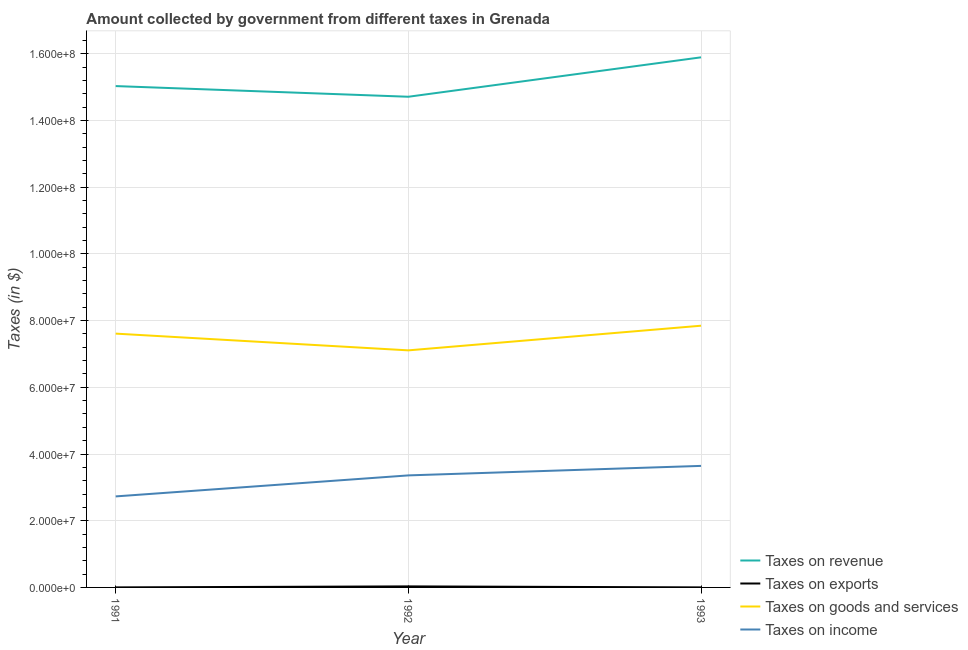What is the amount collected as tax on exports in 1992?
Make the answer very short. 3.10e+05. Across all years, what is the maximum amount collected as tax on income?
Provide a short and direct response. 3.64e+07. Across all years, what is the minimum amount collected as tax on goods?
Make the answer very short. 7.11e+07. In which year was the amount collected as tax on income maximum?
Provide a short and direct response. 1993. In which year was the amount collected as tax on goods minimum?
Your answer should be compact. 1992. What is the total amount collected as tax on income in the graph?
Ensure brevity in your answer.  9.73e+07. What is the difference between the amount collected as tax on exports in 1992 and that in 1993?
Ensure brevity in your answer.  3.00e+05. What is the difference between the amount collected as tax on goods in 1992 and the amount collected as tax on exports in 1991?
Give a very brief answer. 7.11e+07. In the year 1993, what is the difference between the amount collected as tax on goods and amount collected as tax on revenue?
Provide a succinct answer. -8.05e+07. Is the amount collected as tax on income in 1992 less than that in 1993?
Provide a succinct answer. Yes. Is the difference between the amount collected as tax on income in 1991 and 1992 greater than the difference between the amount collected as tax on exports in 1991 and 1992?
Provide a succinct answer. No. What is the difference between the highest and the second highest amount collected as tax on goods?
Offer a very short reply. 2.37e+06. What is the difference between the highest and the lowest amount collected as tax on revenue?
Your answer should be compact. 1.18e+07. Is the sum of the amount collected as tax on income in 1992 and 1993 greater than the maximum amount collected as tax on exports across all years?
Keep it short and to the point. Yes. Does the amount collected as tax on goods monotonically increase over the years?
Keep it short and to the point. No. How many lines are there?
Your response must be concise. 4. How many years are there in the graph?
Offer a terse response. 3. What is the difference between two consecutive major ticks on the Y-axis?
Keep it short and to the point. 2.00e+07. Are the values on the major ticks of Y-axis written in scientific E-notation?
Your response must be concise. Yes. Does the graph contain any zero values?
Give a very brief answer. No. What is the title of the graph?
Give a very brief answer. Amount collected by government from different taxes in Grenada. What is the label or title of the X-axis?
Provide a succinct answer. Year. What is the label or title of the Y-axis?
Your answer should be compact. Taxes (in $). What is the Taxes (in $) in Taxes on revenue in 1991?
Offer a very short reply. 1.50e+08. What is the Taxes (in $) in Taxes on exports in 1991?
Provide a succinct answer. 10000. What is the Taxes (in $) in Taxes on goods and services in 1991?
Provide a short and direct response. 7.61e+07. What is the Taxes (in $) of Taxes on income in 1991?
Your response must be concise. 2.73e+07. What is the Taxes (in $) in Taxes on revenue in 1992?
Your answer should be very brief. 1.47e+08. What is the Taxes (in $) in Taxes on goods and services in 1992?
Provide a short and direct response. 7.11e+07. What is the Taxes (in $) in Taxes on income in 1992?
Offer a terse response. 3.36e+07. What is the Taxes (in $) in Taxes on revenue in 1993?
Make the answer very short. 1.59e+08. What is the Taxes (in $) of Taxes on goods and services in 1993?
Your answer should be compact. 7.85e+07. What is the Taxes (in $) in Taxes on income in 1993?
Your answer should be compact. 3.64e+07. Across all years, what is the maximum Taxes (in $) in Taxes on revenue?
Give a very brief answer. 1.59e+08. Across all years, what is the maximum Taxes (in $) in Taxes on exports?
Provide a short and direct response. 3.10e+05. Across all years, what is the maximum Taxes (in $) of Taxes on goods and services?
Offer a terse response. 7.85e+07. Across all years, what is the maximum Taxes (in $) in Taxes on income?
Give a very brief answer. 3.64e+07. Across all years, what is the minimum Taxes (in $) in Taxes on revenue?
Provide a short and direct response. 1.47e+08. Across all years, what is the minimum Taxes (in $) of Taxes on goods and services?
Your answer should be compact. 7.11e+07. Across all years, what is the minimum Taxes (in $) in Taxes on income?
Provide a short and direct response. 2.73e+07. What is the total Taxes (in $) of Taxes on revenue in the graph?
Give a very brief answer. 4.56e+08. What is the total Taxes (in $) of Taxes on goods and services in the graph?
Offer a very short reply. 2.26e+08. What is the total Taxes (in $) of Taxes on income in the graph?
Keep it short and to the point. 9.73e+07. What is the difference between the Taxes (in $) of Taxes on revenue in 1991 and that in 1992?
Offer a very short reply. 3.20e+06. What is the difference between the Taxes (in $) of Taxes on exports in 1991 and that in 1992?
Make the answer very short. -3.00e+05. What is the difference between the Taxes (in $) in Taxes on goods and services in 1991 and that in 1992?
Your answer should be very brief. 5.02e+06. What is the difference between the Taxes (in $) in Taxes on income in 1991 and that in 1992?
Provide a succinct answer. -6.30e+06. What is the difference between the Taxes (in $) of Taxes on revenue in 1991 and that in 1993?
Make the answer very short. -8.62e+06. What is the difference between the Taxes (in $) in Taxes on goods and services in 1991 and that in 1993?
Make the answer very short. -2.37e+06. What is the difference between the Taxes (in $) in Taxes on income in 1991 and that in 1993?
Your answer should be compact. -9.15e+06. What is the difference between the Taxes (in $) of Taxes on revenue in 1992 and that in 1993?
Offer a terse response. -1.18e+07. What is the difference between the Taxes (in $) in Taxes on exports in 1992 and that in 1993?
Ensure brevity in your answer.  3.00e+05. What is the difference between the Taxes (in $) in Taxes on goods and services in 1992 and that in 1993?
Offer a very short reply. -7.39e+06. What is the difference between the Taxes (in $) in Taxes on income in 1992 and that in 1993?
Offer a terse response. -2.85e+06. What is the difference between the Taxes (in $) of Taxes on revenue in 1991 and the Taxes (in $) of Taxes on exports in 1992?
Offer a very short reply. 1.50e+08. What is the difference between the Taxes (in $) in Taxes on revenue in 1991 and the Taxes (in $) in Taxes on goods and services in 1992?
Keep it short and to the point. 7.92e+07. What is the difference between the Taxes (in $) of Taxes on revenue in 1991 and the Taxes (in $) of Taxes on income in 1992?
Keep it short and to the point. 1.17e+08. What is the difference between the Taxes (in $) in Taxes on exports in 1991 and the Taxes (in $) in Taxes on goods and services in 1992?
Your response must be concise. -7.11e+07. What is the difference between the Taxes (in $) in Taxes on exports in 1991 and the Taxes (in $) in Taxes on income in 1992?
Ensure brevity in your answer.  -3.36e+07. What is the difference between the Taxes (in $) of Taxes on goods and services in 1991 and the Taxes (in $) of Taxes on income in 1992?
Your answer should be compact. 4.25e+07. What is the difference between the Taxes (in $) of Taxes on revenue in 1991 and the Taxes (in $) of Taxes on exports in 1993?
Offer a terse response. 1.50e+08. What is the difference between the Taxes (in $) of Taxes on revenue in 1991 and the Taxes (in $) of Taxes on goods and services in 1993?
Provide a succinct answer. 7.18e+07. What is the difference between the Taxes (in $) in Taxes on revenue in 1991 and the Taxes (in $) in Taxes on income in 1993?
Keep it short and to the point. 1.14e+08. What is the difference between the Taxes (in $) of Taxes on exports in 1991 and the Taxes (in $) of Taxes on goods and services in 1993?
Offer a very short reply. -7.85e+07. What is the difference between the Taxes (in $) in Taxes on exports in 1991 and the Taxes (in $) in Taxes on income in 1993?
Provide a short and direct response. -3.64e+07. What is the difference between the Taxes (in $) of Taxes on goods and services in 1991 and the Taxes (in $) of Taxes on income in 1993?
Your answer should be very brief. 3.97e+07. What is the difference between the Taxes (in $) of Taxes on revenue in 1992 and the Taxes (in $) of Taxes on exports in 1993?
Give a very brief answer. 1.47e+08. What is the difference between the Taxes (in $) of Taxes on revenue in 1992 and the Taxes (in $) of Taxes on goods and services in 1993?
Give a very brief answer. 6.86e+07. What is the difference between the Taxes (in $) in Taxes on revenue in 1992 and the Taxes (in $) in Taxes on income in 1993?
Offer a very short reply. 1.11e+08. What is the difference between the Taxes (in $) of Taxes on exports in 1992 and the Taxes (in $) of Taxes on goods and services in 1993?
Provide a short and direct response. -7.82e+07. What is the difference between the Taxes (in $) of Taxes on exports in 1992 and the Taxes (in $) of Taxes on income in 1993?
Your answer should be compact. -3.61e+07. What is the difference between the Taxes (in $) of Taxes on goods and services in 1992 and the Taxes (in $) of Taxes on income in 1993?
Your answer should be very brief. 3.46e+07. What is the average Taxes (in $) of Taxes on revenue per year?
Provide a succinct answer. 1.52e+08. What is the average Taxes (in $) of Taxes on goods and services per year?
Ensure brevity in your answer.  7.52e+07. What is the average Taxes (in $) in Taxes on income per year?
Offer a terse response. 3.24e+07. In the year 1991, what is the difference between the Taxes (in $) in Taxes on revenue and Taxes (in $) in Taxes on exports?
Give a very brief answer. 1.50e+08. In the year 1991, what is the difference between the Taxes (in $) of Taxes on revenue and Taxes (in $) of Taxes on goods and services?
Offer a very short reply. 7.42e+07. In the year 1991, what is the difference between the Taxes (in $) in Taxes on revenue and Taxes (in $) in Taxes on income?
Ensure brevity in your answer.  1.23e+08. In the year 1991, what is the difference between the Taxes (in $) in Taxes on exports and Taxes (in $) in Taxes on goods and services?
Give a very brief answer. -7.61e+07. In the year 1991, what is the difference between the Taxes (in $) in Taxes on exports and Taxes (in $) in Taxes on income?
Offer a terse response. -2.73e+07. In the year 1991, what is the difference between the Taxes (in $) in Taxes on goods and services and Taxes (in $) in Taxes on income?
Your response must be concise. 4.88e+07. In the year 1992, what is the difference between the Taxes (in $) in Taxes on revenue and Taxes (in $) in Taxes on exports?
Your response must be concise. 1.47e+08. In the year 1992, what is the difference between the Taxes (in $) of Taxes on revenue and Taxes (in $) of Taxes on goods and services?
Give a very brief answer. 7.60e+07. In the year 1992, what is the difference between the Taxes (in $) of Taxes on revenue and Taxes (in $) of Taxes on income?
Keep it short and to the point. 1.14e+08. In the year 1992, what is the difference between the Taxes (in $) of Taxes on exports and Taxes (in $) of Taxes on goods and services?
Give a very brief answer. -7.08e+07. In the year 1992, what is the difference between the Taxes (in $) of Taxes on exports and Taxes (in $) of Taxes on income?
Keep it short and to the point. -3.33e+07. In the year 1992, what is the difference between the Taxes (in $) in Taxes on goods and services and Taxes (in $) in Taxes on income?
Make the answer very short. 3.75e+07. In the year 1993, what is the difference between the Taxes (in $) in Taxes on revenue and Taxes (in $) in Taxes on exports?
Offer a terse response. 1.59e+08. In the year 1993, what is the difference between the Taxes (in $) in Taxes on revenue and Taxes (in $) in Taxes on goods and services?
Your response must be concise. 8.05e+07. In the year 1993, what is the difference between the Taxes (in $) of Taxes on revenue and Taxes (in $) of Taxes on income?
Make the answer very short. 1.22e+08. In the year 1993, what is the difference between the Taxes (in $) of Taxes on exports and Taxes (in $) of Taxes on goods and services?
Give a very brief answer. -7.85e+07. In the year 1993, what is the difference between the Taxes (in $) of Taxes on exports and Taxes (in $) of Taxes on income?
Provide a short and direct response. -3.64e+07. In the year 1993, what is the difference between the Taxes (in $) of Taxes on goods and services and Taxes (in $) of Taxes on income?
Make the answer very short. 4.20e+07. What is the ratio of the Taxes (in $) in Taxes on revenue in 1991 to that in 1992?
Offer a terse response. 1.02. What is the ratio of the Taxes (in $) of Taxes on exports in 1991 to that in 1992?
Give a very brief answer. 0.03. What is the ratio of the Taxes (in $) of Taxes on goods and services in 1991 to that in 1992?
Give a very brief answer. 1.07. What is the ratio of the Taxes (in $) in Taxes on income in 1991 to that in 1992?
Ensure brevity in your answer.  0.81. What is the ratio of the Taxes (in $) of Taxes on revenue in 1991 to that in 1993?
Your answer should be very brief. 0.95. What is the ratio of the Taxes (in $) in Taxes on goods and services in 1991 to that in 1993?
Give a very brief answer. 0.97. What is the ratio of the Taxes (in $) of Taxes on income in 1991 to that in 1993?
Your answer should be compact. 0.75. What is the ratio of the Taxes (in $) in Taxes on revenue in 1992 to that in 1993?
Offer a very short reply. 0.93. What is the ratio of the Taxes (in $) of Taxes on exports in 1992 to that in 1993?
Provide a short and direct response. 31. What is the ratio of the Taxes (in $) of Taxes on goods and services in 1992 to that in 1993?
Give a very brief answer. 0.91. What is the ratio of the Taxes (in $) in Taxes on income in 1992 to that in 1993?
Your response must be concise. 0.92. What is the difference between the highest and the second highest Taxes (in $) in Taxes on revenue?
Your answer should be compact. 8.62e+06. What is the difference between the highest and the second highest Taxes (in $) in Taxes on exports?
Offer a very short reply. 3.00e+05. What is the difference between the highest and the second highest Taxes (in $) in Taxes on goods and services?
Your response must be concise. 2.37e+06. What is the difference between the highest and the second highest Taxes (in $) in Taxes on income?
Offer a terse response. 2.85e+06. What is the difference between the highest and the lowest Taxes (in $) in Taxes on revenue?
Provide a succinct answer. 1.18e+07. What is the difference between the highest and the lowest Taxes (in $) of Taxes on exports?
Offer a very short reply. 3.00e+05. What is the difference between the highest and the lowest Taxes (in $) of Taxes on goods and services?
Keep it short and to the point. 7.39e+06. What is the difference between the highest and the lowest Taxes (in $) of Taxes on income?
Keep it short and to the point. 9.15e+06. 